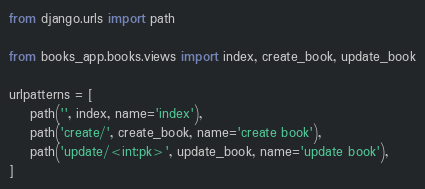Convert code to text. <code><loc_0><loc_0><loc_500><loc_500><_Python_>from django.urls import path

from books_app.books.views import index, create_book, update_book

urlpatterns = [
    path('', index, name='index'),
    path('create/', create_book, name='create book'),
    path('update/<int:pk>', update_book, name='update book'),
]</code> 